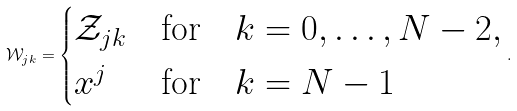Convert formula to latex. <formula><loc_0><loc_0><loc_500><loc_500>\mathcal { W } _ { j k } = \begin{cases} \mathcal { Z } _ { j k } & \text {for} \quad k = 0 , \dots , N - 2 , \\ x ^ { j } & \text {for} \quad k = N - 1 \end{cases} .</formula> 